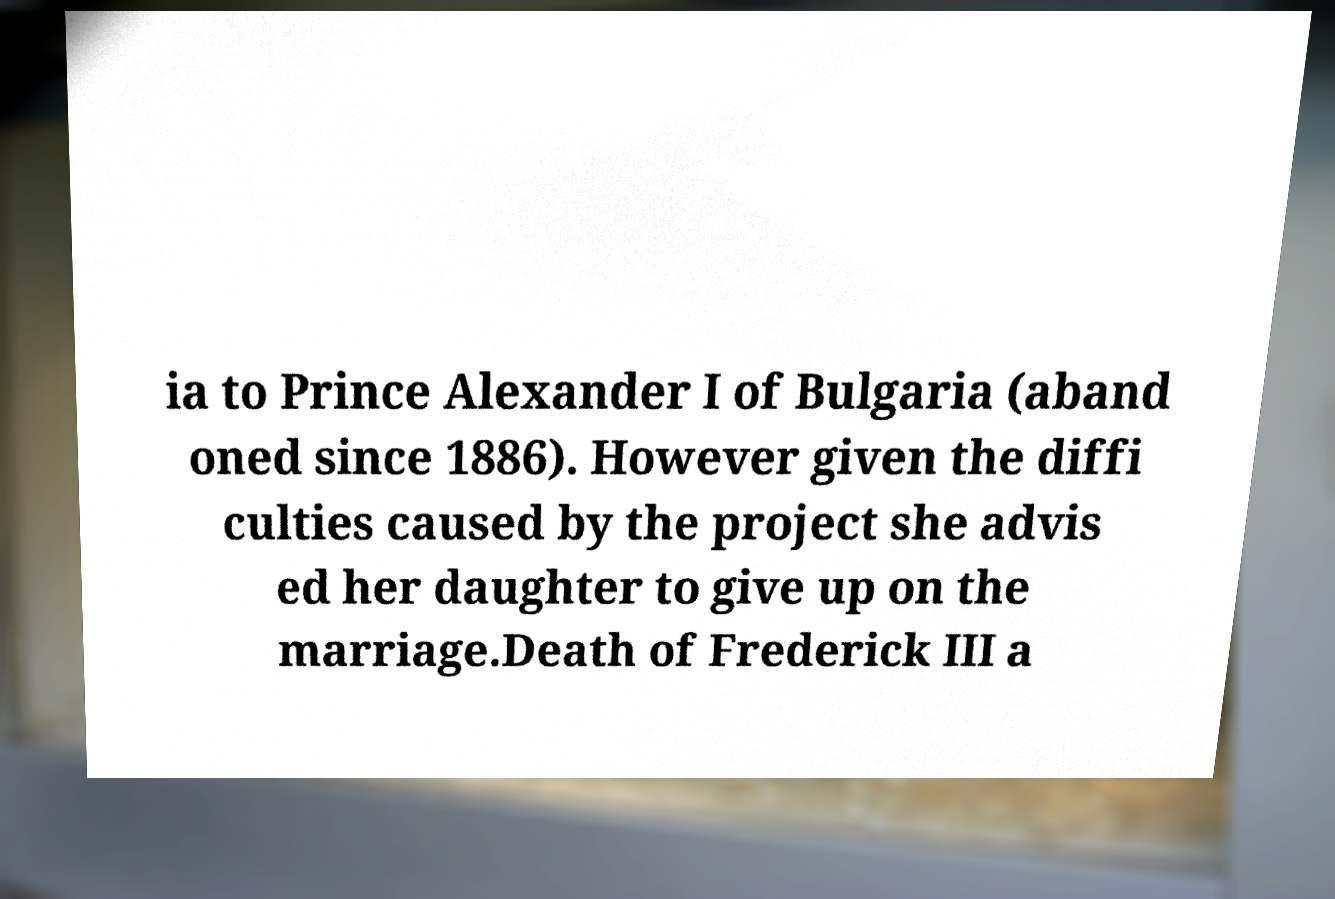There's text embedded in this image that I need extracted. Can you transcribe it verbatim? ia to Prince Alexander I of Bulgaria (aband oned since 1886). However given the diffi culties caused by the project she advis ed her daughter to give up on the marriage.Death of Frederick III a 